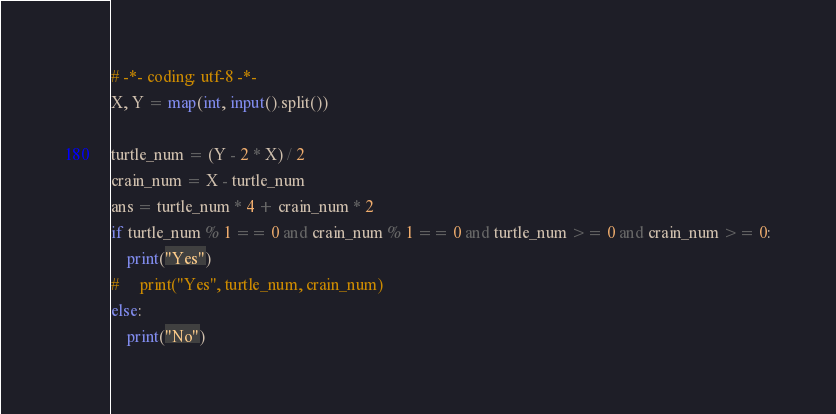Convert code to text. <code><loc_0><loc_0><loc_500><loc_500><_Python_># -*- coding: utf-8 -*-
X, Y = map(int, input().split())

turtle_num = (Y - 2 * X) / 2
crain_num = X - turtle_num
ans = turtle_num * 4 + crain_num * 2
if turtle_num % 1 == 0 and crain_num % 1 == 0 and turtle_num >= 0 and crain_num >= 0:
    print("Yes")
#     print("Yes", turtle_num, crain_num)
else:
    print("No")</code> 